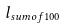<formula> <loc_0><loc_0><loc_500><loc_500>l _ { s u m o f 1 0 0 }</formula> 